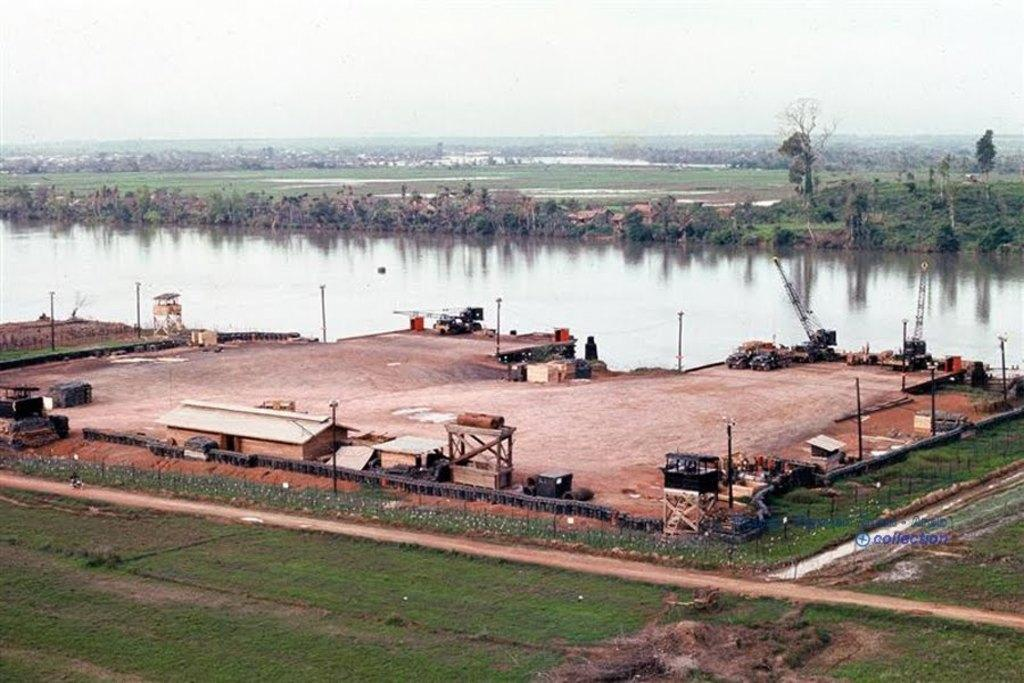What type of structures can be seen in the image? There are shelters in the image. What type of vegetation is present in the image? There is grass, trees, and plants in the image. What type of objects can be seen in the image? There are poles, cranes, and shelters in the image. What is visible in the background of the image? The sky is visible in the image. What type of surface is visible in the image? There is water visible in the image. Can you tell me how many doctors are present in the image? There are no doctors present in the image. What type of system is being used by the group in the image? There is no group or system present in the image. 